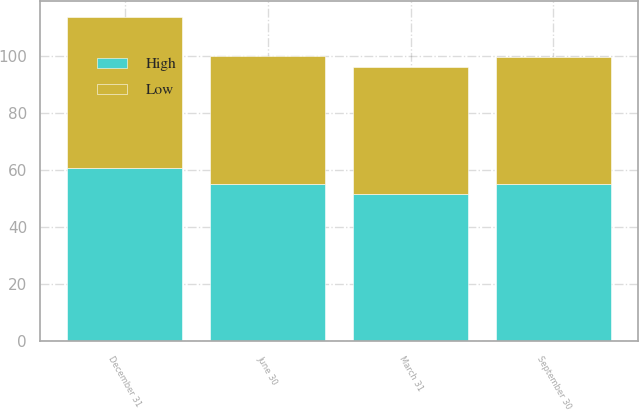Convert chart to OTSL. <chart><loc_0><loc_0><loc_500><loc_500><stacked_bar_chart><ecel><fcel>March 31<fcel>June 30<fcel>September 30<fcel>December 31<nl><fcel>High<fcel>51.58<fcel>55.27<fcel>55.09<fcel>60.64<nl><fcel>Low<fcel>44.8<fcel>44.93<fcel>44.85<fcel>53.11<nl></chart> 